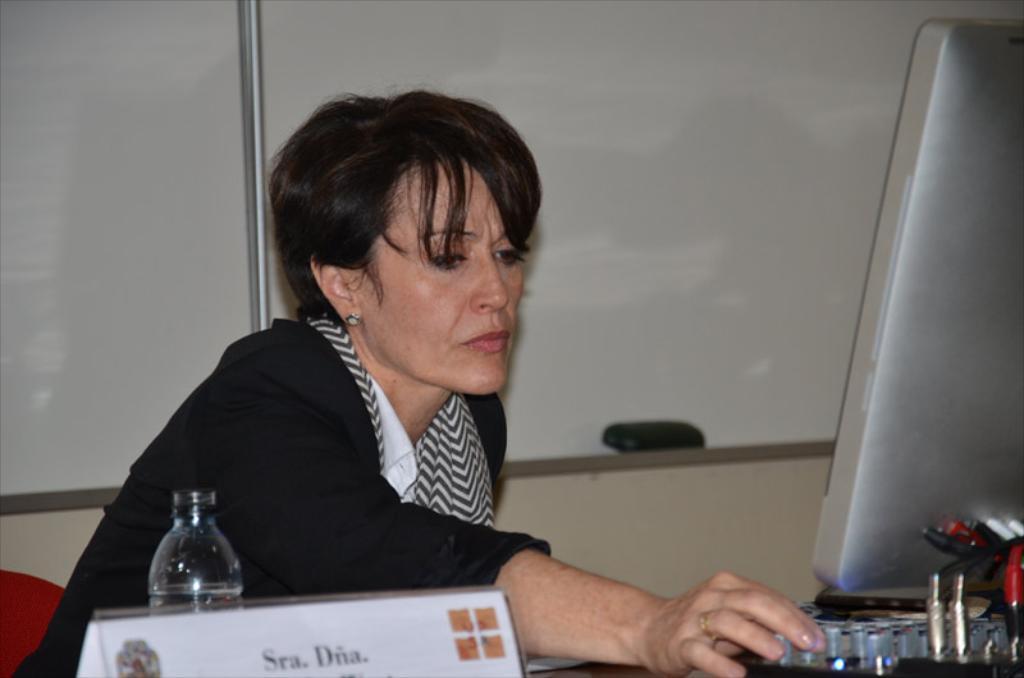Please provide a concise description of this image. On the left side of the image a lady is sitting, in-front of her we can a bottle, naming board, screen are present. At the top of the image boards and wall are there. 